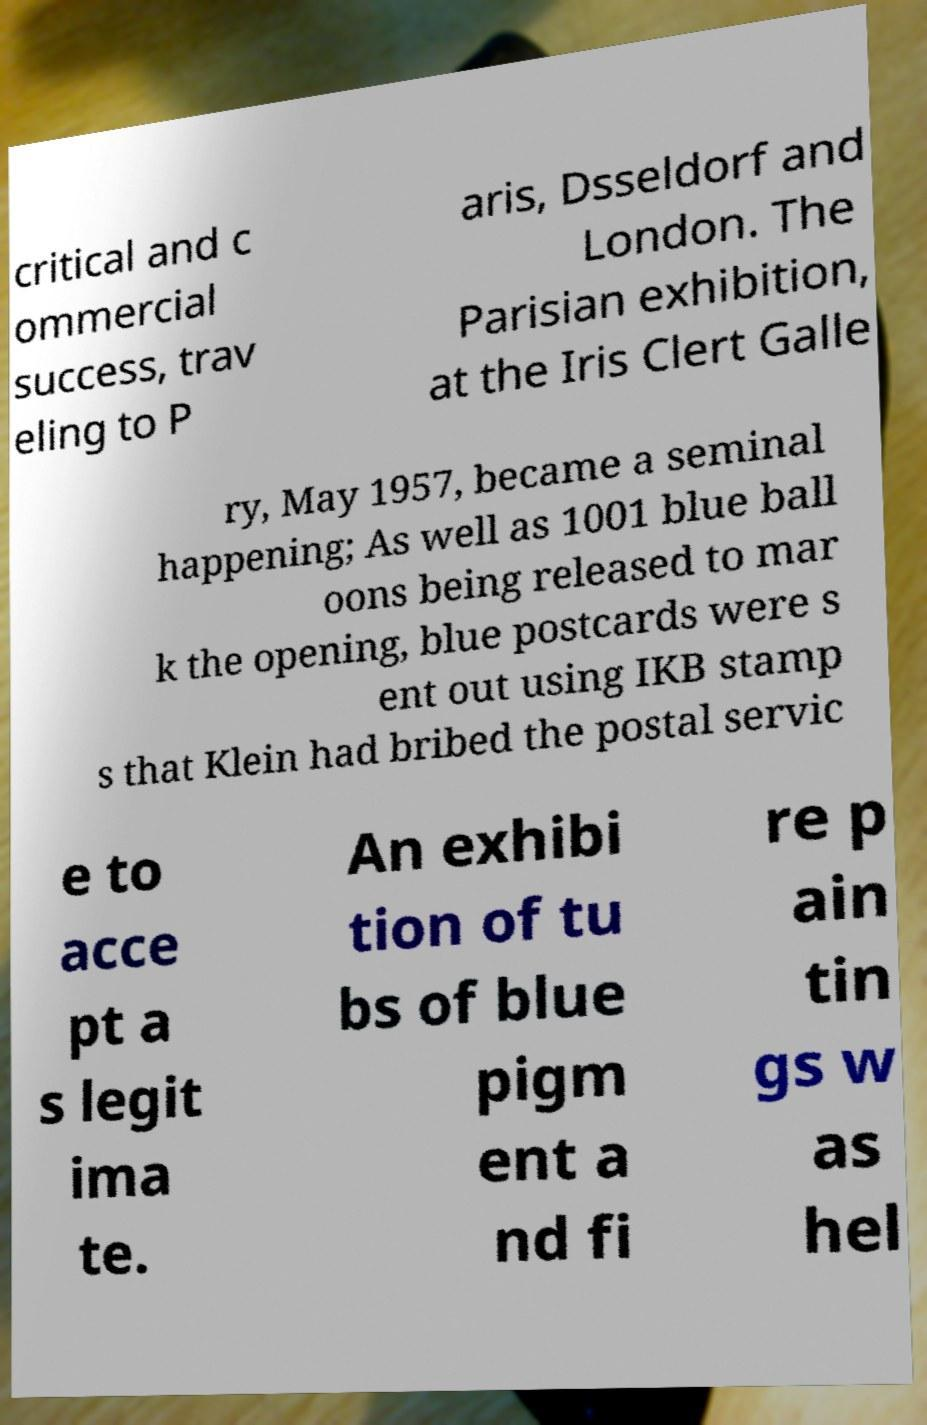There's text embedded in this image that I need extracted. Can you transcribe it verbatim? critical and c ommercial success, trav eling to P aris, Dsseldorf and London. The Parisian exhibition, at the Iris Clert Galle ry, May 1957, became a seminal happening; As well as 1001 blue ball oons being released to mar k the opening, blue postcards were s ent out using IKB stamp s that Klein had bribed the postal servic e to acce pt a s legit ima te. An exhibi tion of tu bs of blue pigm ent a nd fi re p ain tin gs w as hel 